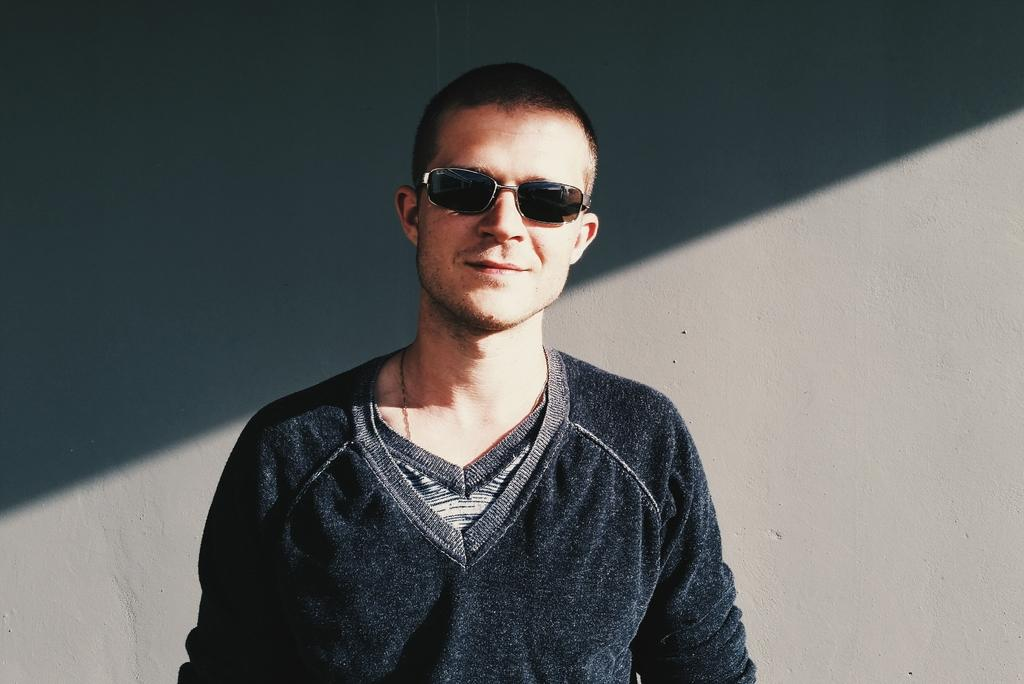Who or what is the main subject of the image? There is a person in the image. What is the person wearing? The person is wearing a black dress. What can be seen in the background of the image? The background of the image is gray. Can you see the person playing a guitar in the image? There is no guitar present in the image, so it cannot be determined if the person is playing one. 